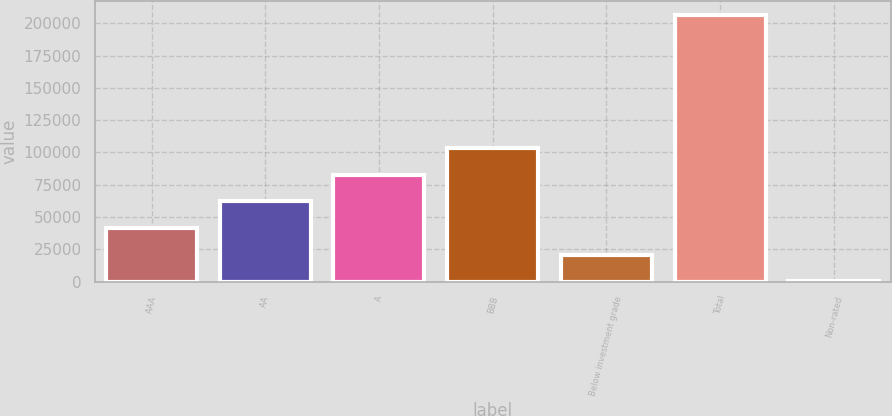Convert chart to OTSL. <chart><loc_0><loc_0><loc_500><loc_500><bar_chart><fcel>AAA<fcel>AA<fcel>A<fcel>BBB<fcel>Below investment grade<fcel>Total<fcel>Non-rated<nl><fcel>41449.4<fcel>62099.6<fcel>82749.8<fcel>103400<fcel>20799.2<fcel>206651<fcel>149<nl></chart> 